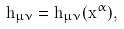<formula> <loc_0><loc_0><loc_500><loc_500>h _ { \mu \nu } = h _ { \mu \nu } ( x ^ { \alpha } ) ,</formula> 